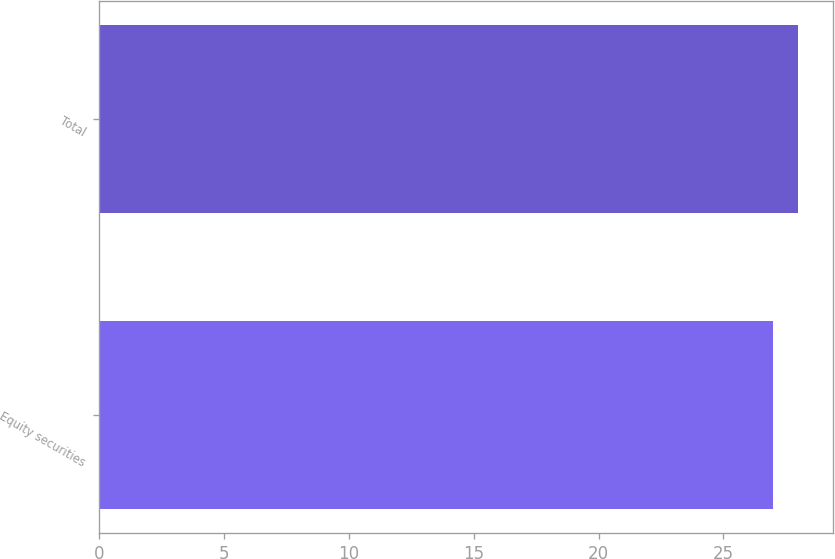Convert chart. <chart><loc_0><loc_0><loc_500><loc_500><bar_chart><fcel>Equity securities<fcel>Total<nl><fcel>27<fcel>28<nl></chart> 